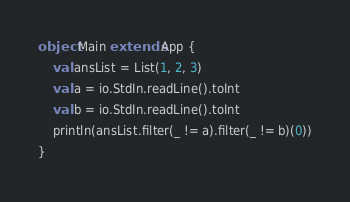<code> <loc_0><loc_0><loc_500><loc_500><_Scala_>object Main extends App {
    val ansList = List(1, 2, 3)
    val a = io.StdIn.readLine().toInt
    val b = io.StdIn.readLine().toInt
    println(ansList.filter(_ != a).filter(_ != b)(0))
}</code> 